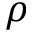<formula> <loc_0><loc_0><loc_500><loc_500>\rho</formula> 